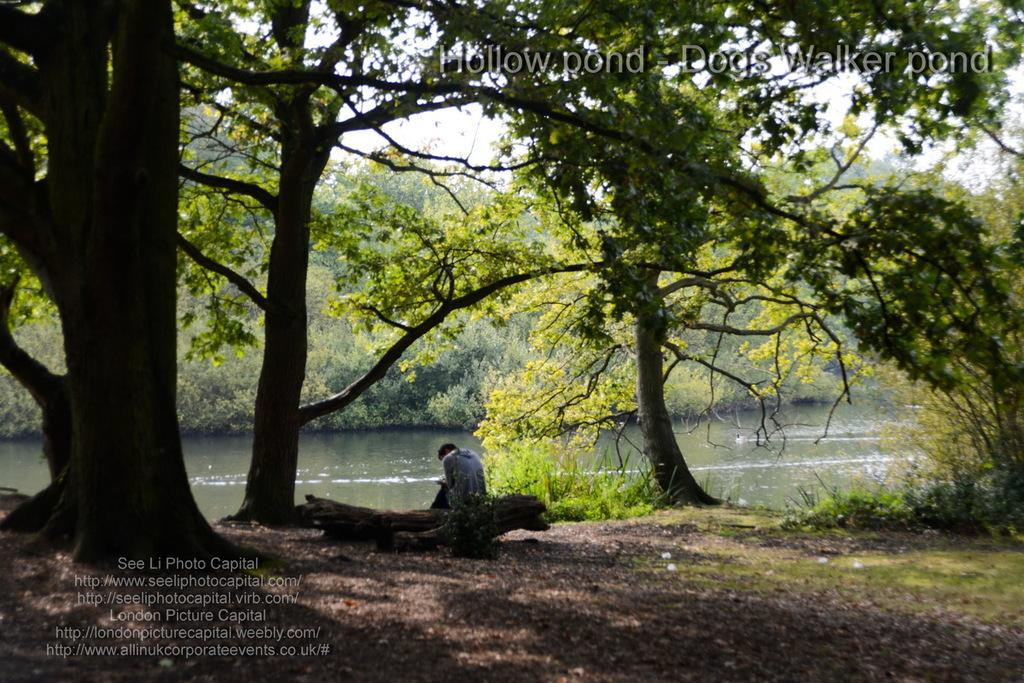What is the main subject of the image? There is a person sitting in the center of the image. What type of natural environment is depicted in the image? There are trees and grass on the ground in the image, which suggests a natural setting. What can be seen in the background of the image? There is water and trees visible in the background of the image. What type of bed is visible in the image? There is no bed present in the image. What is the person competing against in the image? There is no competition depicted in the image; it simply shows a person sitting in a natural setting. 